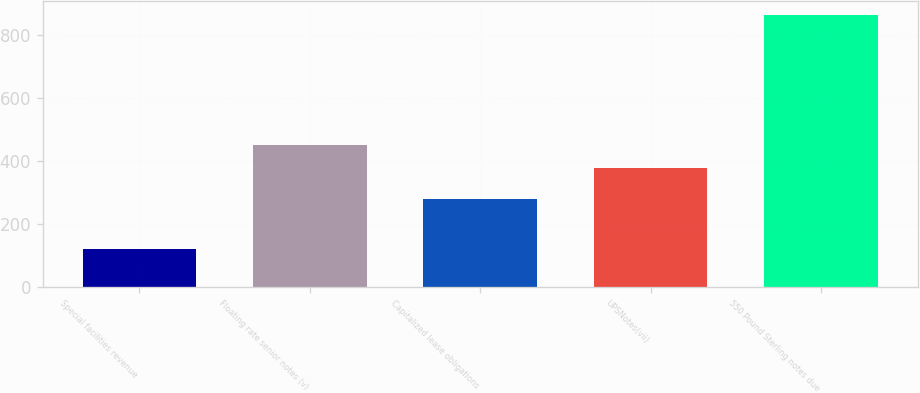<chart> <loc_0><loc_0><loc_500><loc_500><bar_chart><fcel>Special facilities revenue<fcel>Floating rate senior notes (v)<fcel>Capitalized lease obligations<fcel>UPSNotes(vii)<fcel>550 Pound Sterling notes due<nl><fcel>119<fcel>451.4<fcel>278<fcel>377<fcel>863<nl></chart> 